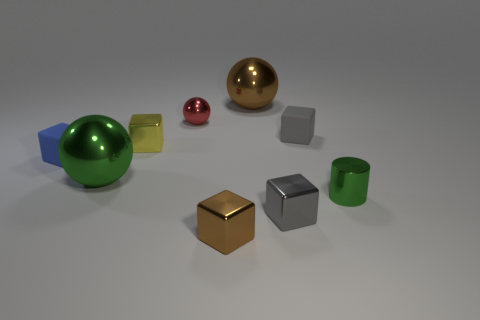Subtract all brown balls. How many balls are left? 2 Subtract all brown spheres. How many spheres are left? 2 Subtract 3 balls. How many balls are left? 0 Subtract all purple balls. How many gray cubes are left? 2 Add 5 tiny green cylinders. How many tiny green cylinders are left? 6 Add 1 red spheres. How many red spheres exist? 2 Subtract 0 purple cylinders. How many objects are left? 9 Subtract all cylinders. How many objects are left? 8 Subtract all yellow spheres. Subtract all green cubes. How many spheres are left? 3 Subtract all large brown spheres. Subtract all things. How many objects are left? 7 